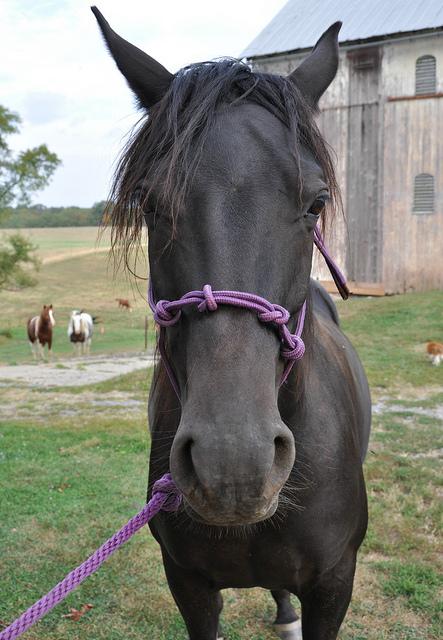Where is the purple rope?
Concise answer only. Horse's nose. Does this look like a typical farm?
Write a very short answer. Yes. Why is the horse tied?
Quick response, please. For use. 